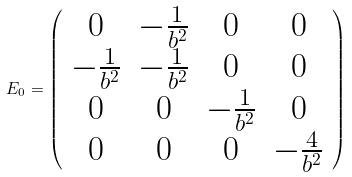<formula> <loc_0><loc_0><loc_500><loc_500>E _ { 0 } = \left ( \begin{array} { c c c c } 0 & - \frac { 1 } { b ^ { 2 } } & 0 & 0 \\ - \frac { 1 } { b ^ { 2 } } & - \frac { 1 } { b ^ { 2 } } & 0 & 0 \\ 0 & 0 & - \frac { 1 } { b ^ { 2 } } & 0 \\ 0 & 0 & 0 & - \frac { 4 } { b ^ { 2 } } \end{array} \right )</formula> 